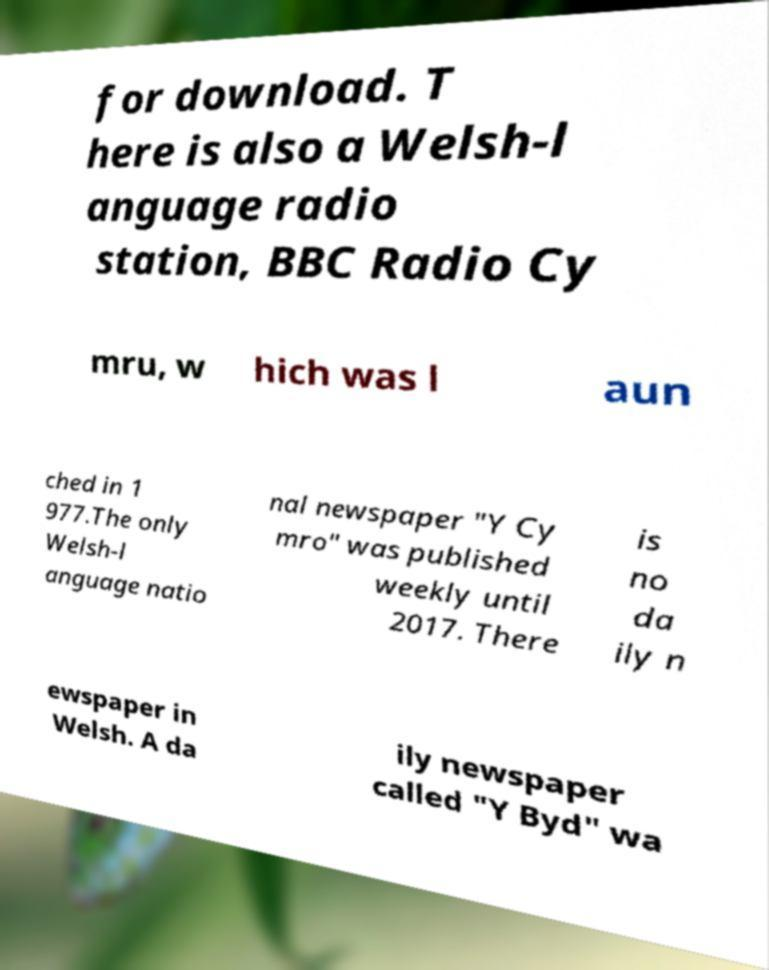What messages or text are displayed in this image? I need them in a readable, typed format. for download. T here is also a Welsh-l anguage radio station, BBC Radio Cy mru, w hich was l aun ched in 1 977.The only Welsh-l anguage natio nal newspaper "Y Cy mro" was published weekly until 2017. There is no da ily n ewspaper in Welsh. A da ily newspaper called "Y Byd" wa 